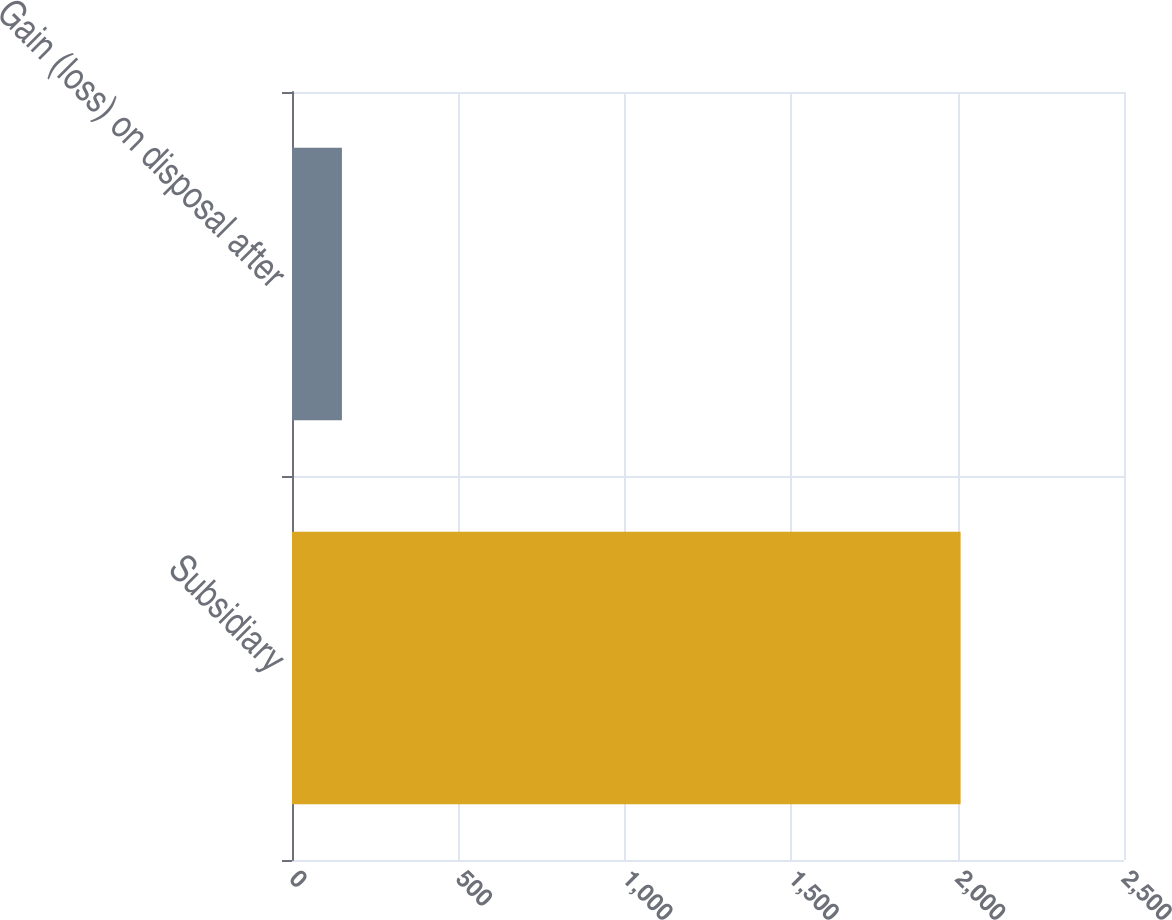Convert chart to OTSL. <chart><loc_0><loc_0><loc_500><loc_500><bar_chart><fcel>Subsidiary<fcel>Gain (loss) on disposal after<nl><fcel>2009<fcel>150<nl></chart> 